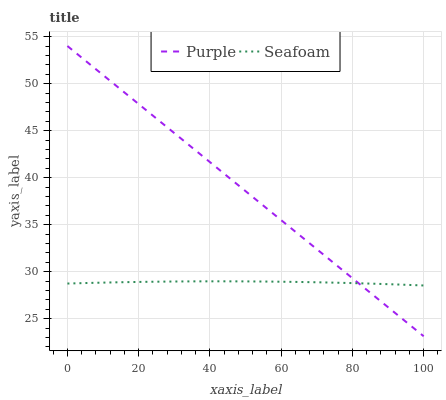Does Seafoam have the minimum area under the curve?
Answer yes or no. Yes. Does Purple have the maximum area under the curve?
Answer yes or no. Yes. Does Seafoam have the maximum area under the curve?
Answer yes or no. No. Is Purple the smoothest?
Answer yes or no. Yes. Is Seafoam the roughest?
Answer yes or no. Yes. Is Seafoam the smoothest?
Answer yes or no. No. Does Purple have the lowest value?
Answer yes or no. Yes. Does Seafoam have the lowest value?
Answer yes or no. No. Does Purple have the highest value?
Answer yes or no. Yes. Does Seafoam have the highest value?
Answer yes or no. No. Does Purple intersect Seafoam?
Answer yes or no. Yes. Is Purple less than Seafoam?
Answer yes or no. No. Is Purple greater than Seafoam?
Answer yes or no. No. 